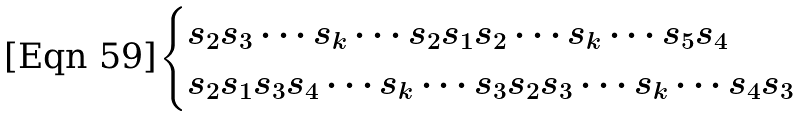Convert formula to latex. <formula><loc_0><loc_0><loc_500><loc_500>\begin{cases} s _ { 2 } s _ { 3 } \cdots s _ { k } \cdots s _ { 2 } s _ { 1 } s _ { 2 } \cdots s _ { k } \cdots s _ { 5 } s _ { 4 } \\ s _ { 2 } s _ { 1 } s _ { 3 } s _ { 4 } \cdots s _ { k } \cdots s _ { 3 } s _ { 2 } s _ { 3 } \cdots s _ { k } \cdots s _ { 4 } s _ { 3 } \end{cases}</formula> 